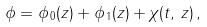Convert formula to latex. <formula><loc_0><loc_0><loc_500><loc_500>\phi = \phi _ { \, 0 } ( z ) + \phi _ { \, 1 } ( z ) + \chi ( t , \, z ) \, ,</formula> 